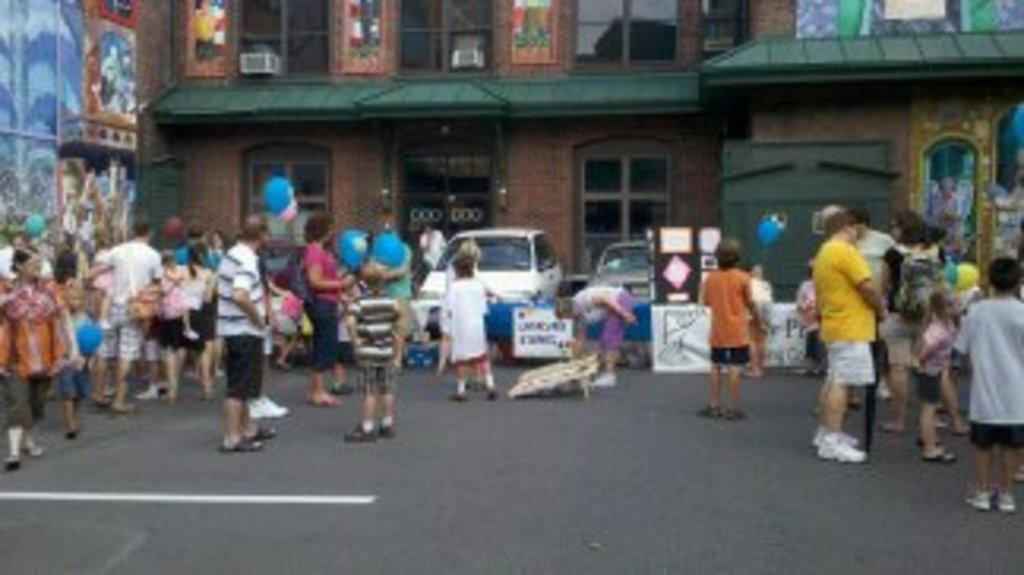What can be seen in the image involving people? There are people standing in the image. What objects are present in the image that are related to boards? There are boards in the image, and there is writing on the boards. What type of objects can be seen in the image that are related to transportation? There are vehicles in the image. What type of structures can be seen in the image? There are buildings in the image. How many cherries are on top of the pie in the image? There is no pie or cherries present in the image. What news is being reported on the boards in the image? There is no news or indication of news reporting on the boards in the image; there is only writing on the boards. 